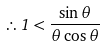<formula> <loc_0><loc_0><loc_500><loc_500>\therefore 1 < { \frac { \sin \theta } { \theta \cos \theta } }</formula> 